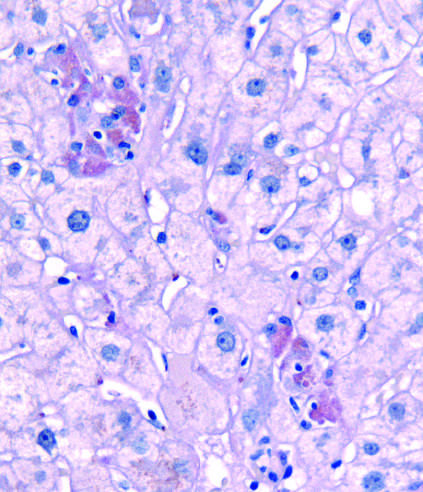do immature myeloid cells indicate foci of hepatocytes undergoing necrosis in this pas-d-stained biopsy from a patient with acute hepatitis b?
Answer the question using a single word or phrase. No 